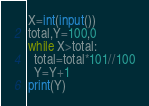Convert code to text. <code><loc_0><loc_0><loc_500><loc_500><_Python_>X=int(input())
total,Y=100,0
while X>total:
  total=total*101//100
  Y=Y+1
print(Y)</code> 